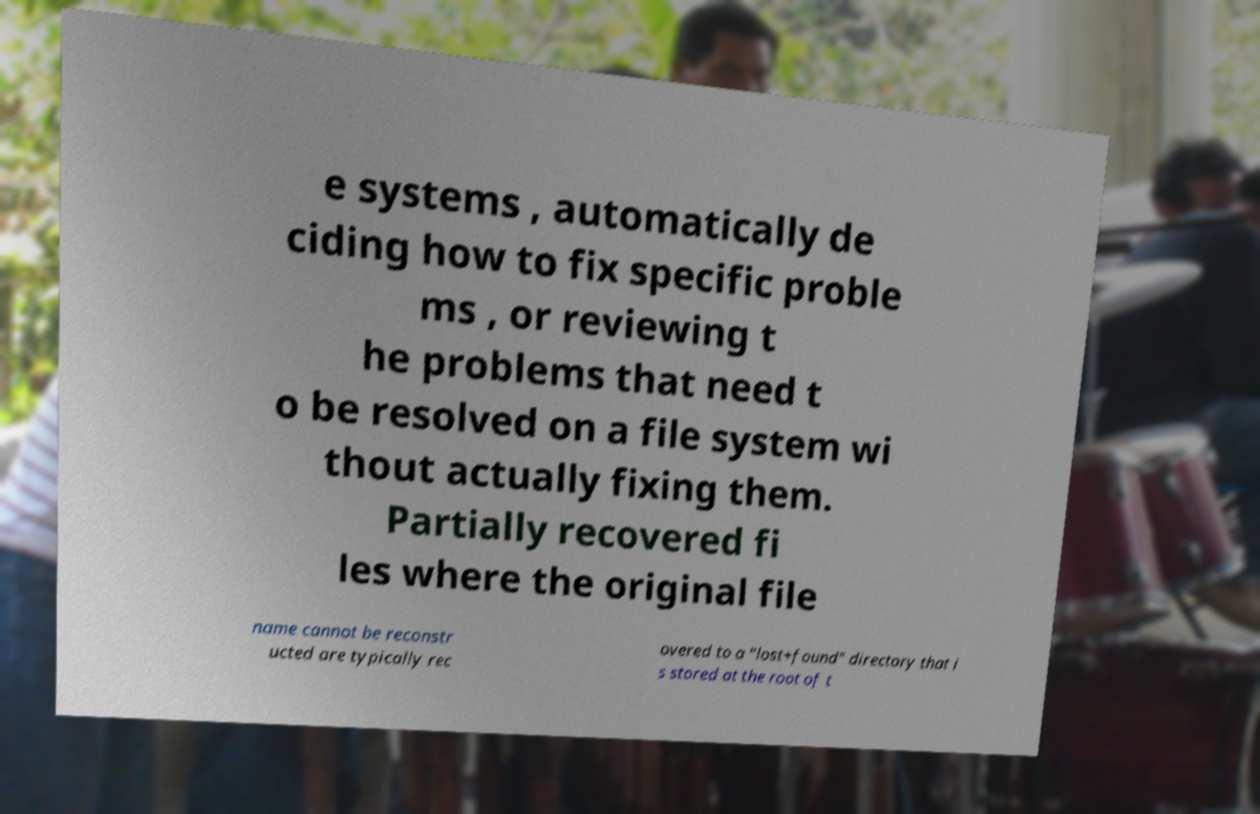Can you accurately transcribe the text from the provided image for me? e systems , automatically de ciding how to fix specific proble ms , or reviewing t he problems that need t o be resolved on a file system wi thout actually fixing them. Partially recovered fi les where the original file name cannot be reconstr ucted are typically rec overed to a "lost+found" directory that i s stored at the root of t 